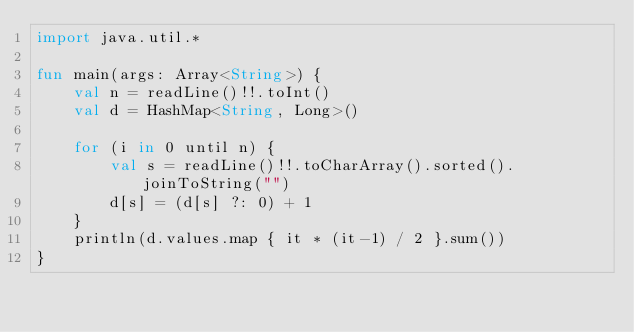<code> <loc_0><loc_0><loc_500><loc_500><_Kotlin_>import java.util.*

fun main(args: Array<String>) {
    val n = readLine()!!.toInt()
    val d = HashMap<String, Long>()

    for (i in 0 until n) {
        val s = readLine()!!.toCharArray().sorted().joinToString("")
        d[s] = (d[s] ?: 0) + 1
    }
    println(d.values.map { it * (it-1) / 2 }.sum())
}</code> 